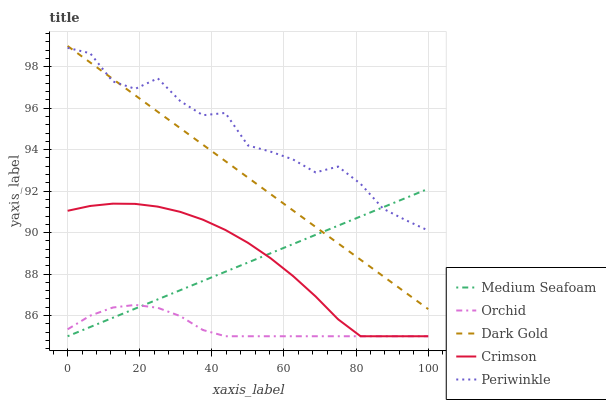Does Orchid have the minimum area under the curve?
Answer yes or no. Yes. Does Periwinkle have the maximum area under the curve?
Answer yes or no. Yes. Does Dark Gold have the minimum area under the curve?
Answer yes or no. No. Does Dark Gold have the maximum area under the curve?
Answer yes or no. No. Is Dark Gold the smoothest?
Answer yes or no. Yes. Is Periwinkle the roughest?
Answer yes or no. Yes. Is Periwinkle the smoothest?
Answer yes or no. No. Is Dark Gold the roughest?
Answer yes or no. No. Does Crimson have the lowest value?
Answer yes or no. Yes. Does Dark Gold have the lowest value?
Answer yes or no. No. Does Dark Gold have the highest value?
Answer yes or no. Yes. Does Periwinkle have the highest value?
Answer yes or no. No. Is Orchid less than Dark Gold?
Answer yes or no. Yes. Is Periwinkle greater than Orchid?
Answer yes or no. Yes. Does Dark Gold intersect Medium Seafoam?
Answer yes or no. Yes. Is Dark Gold less than Medium Seafoam?
Answer yes or no. No. Is Dark Gold greater than Medium Seafoam?
Answer yes or no. No. Does Orchid intersect Dark Gold?
Answer yes or no. No. 